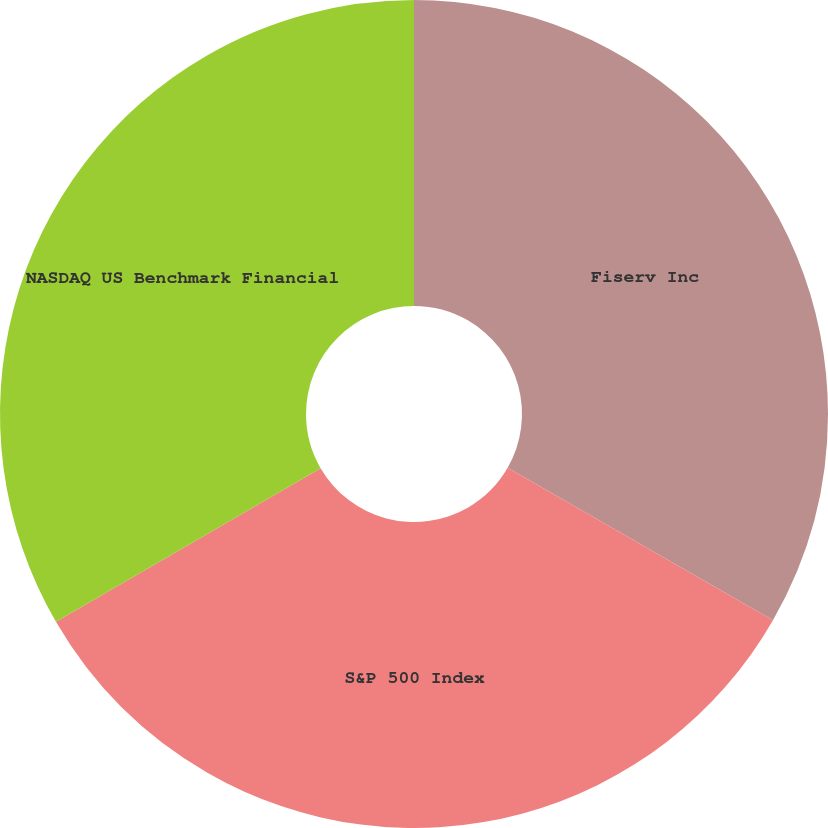<chart> <loc_0><loc_0><loc_500><loc_500><pie_chart><fcel>Fiserv Inc<fcel>S&P 500 Index<fcel>NASDAQ US Benchmark Financial<nl><fcel>33.3%<fcel>33.33%<fcel>33.37%<nl></chart> 